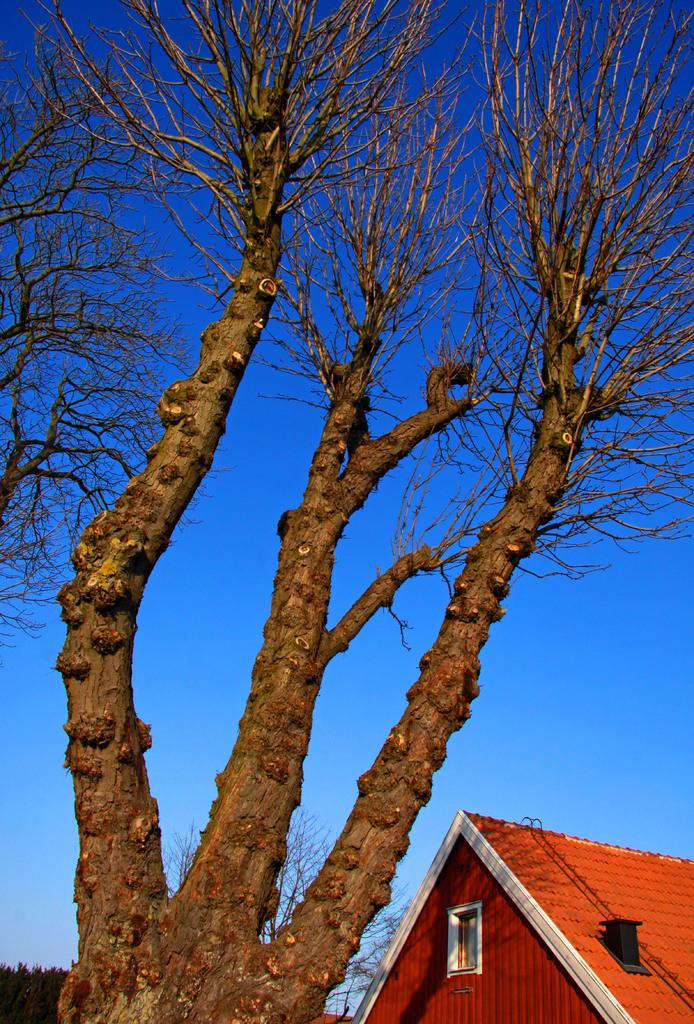What type of setting is depicted in the image? The image is an outside view. What natural elements can be seen in the image? There are trees in the image. Where is the house located in the image? The house is in the bottom right-hand corner of the image. What can be seen in the background of the image? The sky is visible in the background of the image. What is the color of the sky in the image? The color of the sky is blue. What effect does the woman have on the milk in the image? There is no woman or milk present in the image. 